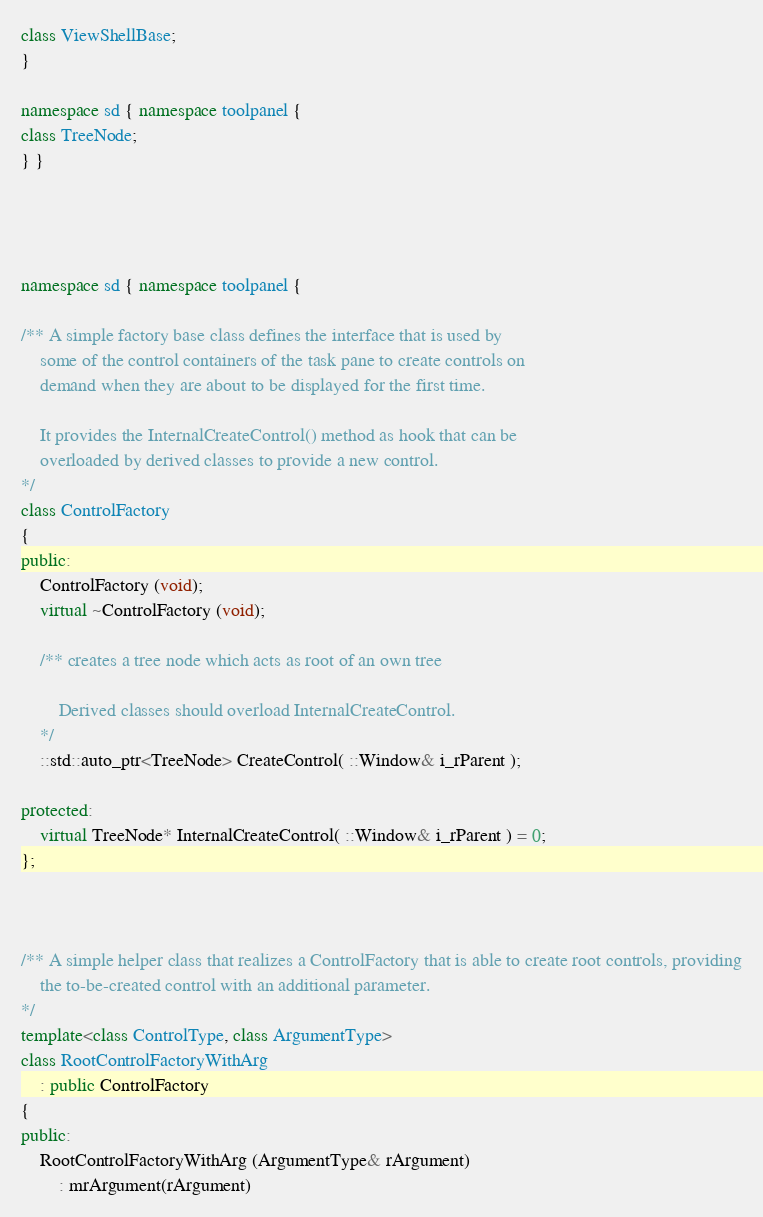Convert code to text. <code><loc_0><loc_0><loc_500><loc_500><_C++_>class ViewShellBase;
}

namespace sd { namespace toolpanel {
class TreeNode;
} }




namespace sd { namespace toolpanel {

/** A simple factory base class defines the interface that is used by
	some of the control containers of the task pane to create controls on
	demand when they are about to be displayed for the first time.

	It provides the InternalCreateControl() method as hook that can be
	overloaded by derived classes to provide a new control.
*/
class ControlFactory
{
public:
	ControlFactory (void);
	virtual ~ControlFactory (void);

	/** creates a tree node which acts as root of an own tree

		Derived classes should overload InternalCreateControl.
	*/
	::std::auto_ptr<TreeNode> CreateControl( ::Window& i_rParent );

protected:
	virtual TreeNode* InternalCreateControl( ::Window& i_rParent ) = 0;
};



/** A simple helper class that realizes a ControlFactory that is able to create root controls, providing
	the to-be-created control with an additional parameter.
*/
template<class ControlType, class ArgumentType>
class RootControlFactoryWithArg
	: public ControlFactory
{
public:
	RootControlFactoryWithArg (ArgumentType& rArgument)
		: mrArgument(rArgument)</code> 